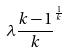<formula> <loc_0><loc_0><loc_500><loc_500>\lambda \frac { k - 1 } { k } ^ { \frac { 1 } { k } }</formula> 